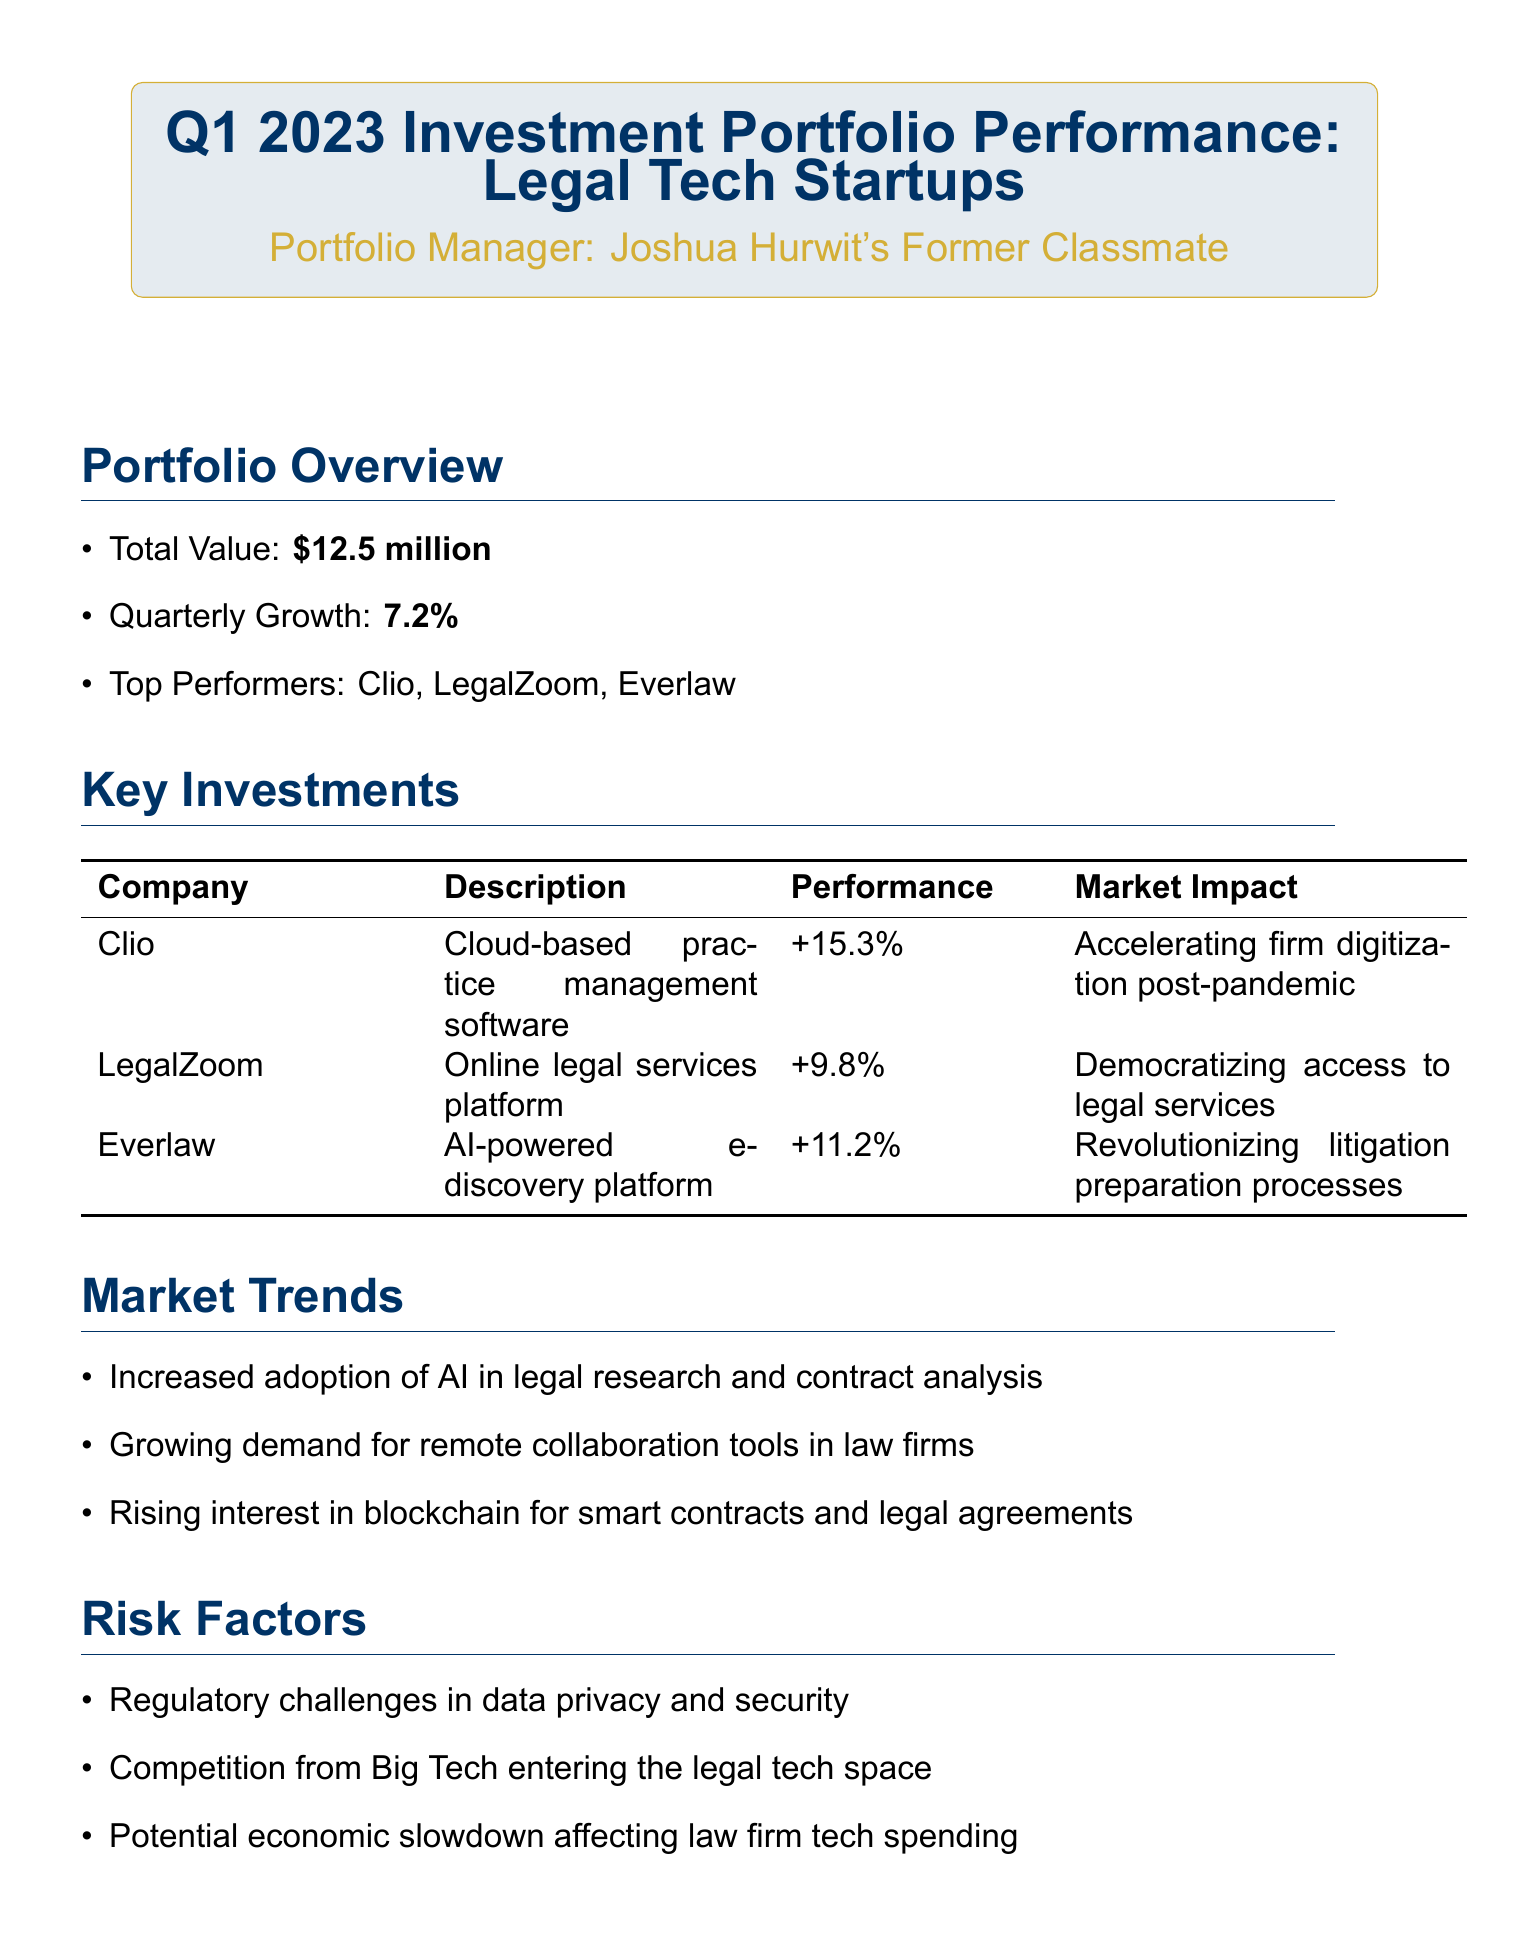What is the total value of the investment portfolio? The total value is mentioned directly in the portfolio overview section, which states it is $12.5 million.
Answer: $12.5 million Which company had the highest performance? The key investments section lists the performance of each company, with Clio showing a performance of +15.3%, the highest among them.
Answer: Clio What is the quarterly growth percentage? The quarterly growth percentage is found in the portfolio overview and is reported as 7.2%.
Answer: 7.2% What market impact is associated with Everlaw? The market impact for Everlaw is stated in the key investments section, describing how it is revolutionizing litigation preparation processes.
Answer: Revolutionizing litigation preparation processes What are the short-term expectations for the portfolio? The outlook section provides a prediction for continued growth in Q2 2023 as the short-term outlook.
Answer: Continued growth expected in Q2 2023 Which risk factor involves potential regulatory challenges? The risk factors section mentions regulatory challenges specifically in the context of data privacy and security issues.
Answer: Regulatory challenges in data privacy and security What trend indicates an increase in technology use in law firms? The market trends list includes increased adoption of AI in legal research and contract analysis.
Answer: Increased adoption of AI in legal research and contract analysis Who is the portfolio manager? The name of the portfolio manager is stated prominently in the document's header box, where it mentions "Joshua Hurwit's Former Classmate."
Answer: Joshua Hurwit's Former Classmate 